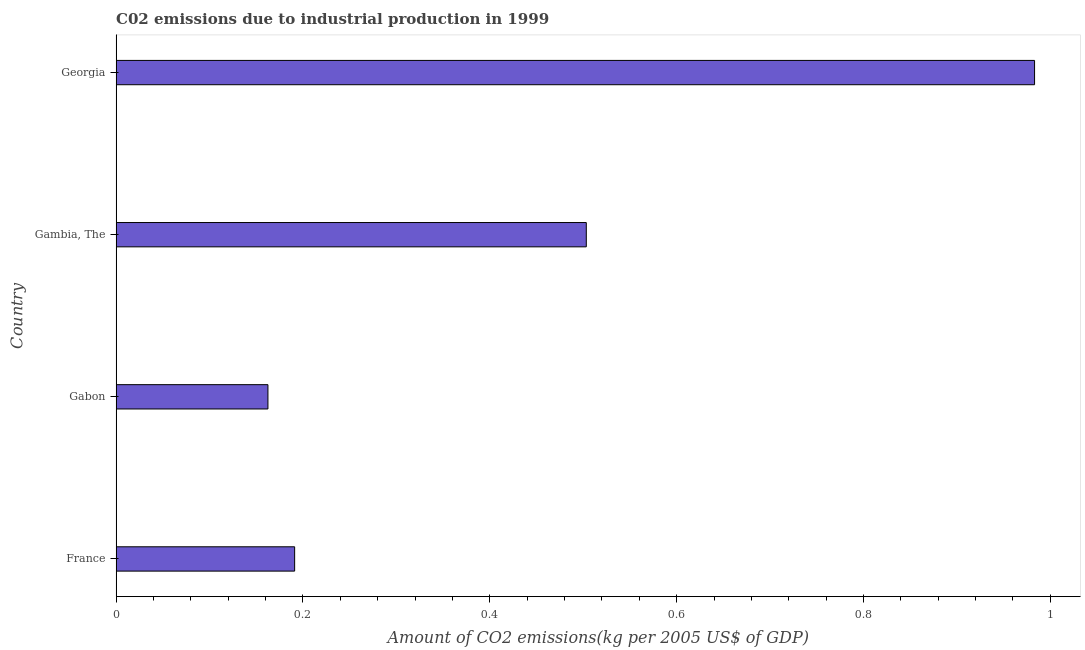Does the graph contain any zero values?
Offer a terse response. No. What is the title of the graph?
Make the answer very short. C02 emissions due to industrial production in 1999. What is the label or title of the X-axis?
Offer a terse response. Amount of CO2 emissions(kg per 2005 US$ of GDP). What is the label or title of the Y-axis?
Ensure brevity in your answer.  Country. What is the amount of co2 emissions in Gambia, The?
Provide a succinct answer. 0.5. Across all countries, what is the maximum amount of co2 emissions?
Your response must be concise. 0.98. Across all countries, what is the minimum amount of co2 emissions?
Offer a terse response. 0.16. In which country was the amount of co2 emissions maximum?
Ensure brevity in your answer.  Georgia. In which country was the amount of co2 emissions minimum?
Offer a very short reply. Gabon. What is the sum of the amount of co2 emissions?
Ensure brevity in your answer.  1.84. What is the difference between the amount of co2 emissions in France and Georgia?
Offer a very short reply. -0.79. What is the average amount of co2 emissions per country?
Ensure brevity in your answer.  0.46. What is the median amount of co2 emissions?
Your answer should be very brief. 0.35. What is the ratio of the amount of co2 emissions in France to that in Gabon?
Keep it short and to the point. 1.18. Is the amount of co2 emissions in Gabon less than that in Georgia?
Ensure brevity in your answer.  Yes. What is the difference between the highest and the second highest amount of co2 emissions?
Offer a terse response. 0.48. What is the difference between the highest and the lowest amount of co2 emissions?
Your response must be concise. 0.82. Are all the bars in the graph horizontal?
Provide a succinct answer. Yes. What is the difference between two consecutive major ticks on the X-axis?
Give a very brief answer. 0.2. What is the Amount of CO2 emissions(kg per 2005 US$ of GDP) in France?
Ensure brevity in your answer.  0.19. What is the Amount of CO2 emissions(kg per 2005 US$ of GDP) of Gabon?
Ensure brevity in your answer.  0.16. What is the Amount of CO2 emissions(kg per 2005 US$ of GDP) in Gambia, The?
Your answer should be compact. 0.5. What is the Amount of CO2 emissions(kg per 2005 US$ of GDP) of Georgia?
Give a very brief answer. 0.98. What is the difference between the Amount of CO2 emissions(kg per 2005 US$ of GDP) in France and Gabon?
Offer a terse response. 0.03. What is the difference between the Amount of CO2 emissions(kg per 2005 US$ of GDP) in France and Gambia, The?
Offer a very short reply. -0.31. What is the difference between the Amount of CO2 emissions(kg per 2005 US$ of GDP) in France and Georgia?
Your answer should be very brief. -0.79. What is the difference between the Amount of CO2 emissions(kg per 2005 US$ of GDP) in Gabon and Gambia, The?
Provide a succinct answer. -0.34. What is the difference between the Amount of CO2 emissions(kg per 2005 US$ of GDP) in Gabon and Georgia?
Your answer should be very brief. -0.82. What is the difference between the Amount of CO2 emissions(kg per 2005 US$ of GDP) in Gambia, The and Georgia?
Give a very brief answer. -0.48. What is the ratio of the Amount of CO2 emissions(kg per 2005 US$ of GDP) in France to that in Gabon?
Give a very brief answer. 1.18. What is the ratio of the Amount of CO2 emissions(kg per 2005 US$ of GDP) in France to that in Gambia, The?
Ensure brevity in your answer.  0.38. What is the ratio of the Amount of CO2 emissions(kg per 2005 US$ of GDP) in France to that in Georgia?
Your answer should be very brief. 0.19. What is the ratio of the Amount of CO2 emissions(kg per 2005 US$ of GDP) in Gabon to that in Gambia, The?
Your answer should be compact. 0.32. What is the ratio of the Amount of CO2 emissions(kg per 2005 US$ of GDP) in Gabon to that in Georgia?
Your answer should be very brief. 0.17. What is the ratio of the Amount of CO2 emissions(kg per 2005 US$ of GDP) in Gambia, The to that in Georgia?
Provide a short and direct response. 0.51. 